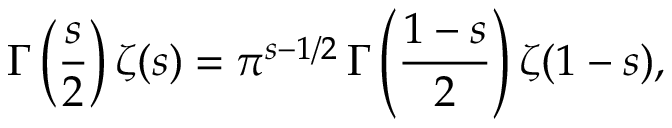Convert formula to latex. <formula><loc_0><loc_0><loc_500><loc_500>\Gamma \left ( \frac { s } { 2 } \right ) \zeta ( s ) = \pi ^ { s - 1 / 2 } \, \Gamma \left ( \frac { 1 - s } { 2 } \right ) \zeta ( 1 - s ) ,</formula> 